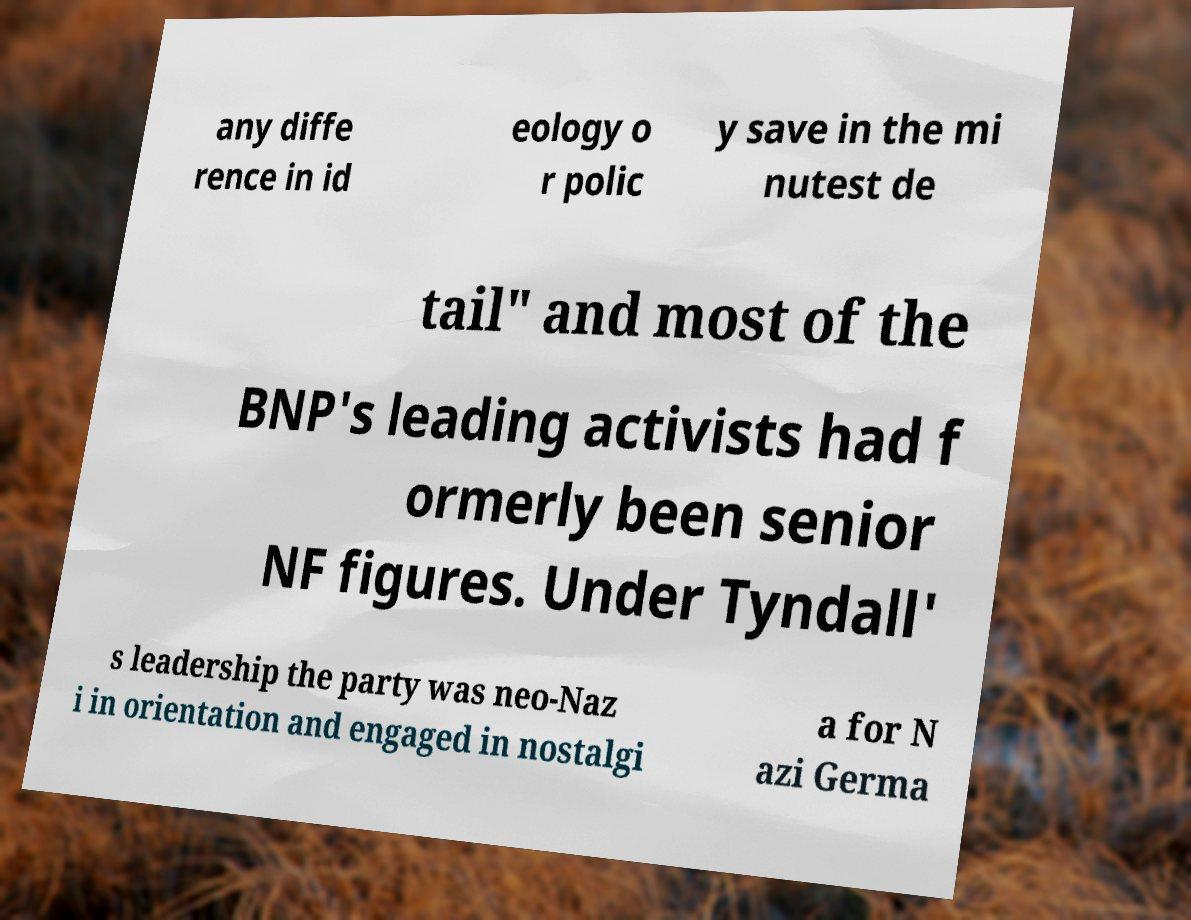I need the written content from this picture converted into text. Can you do that? any diffe rence in id eology o r polic y save in the mi nutest de tail" and most of the BNP's leading activists had f ormerly been senior NF figures. Under Tyndall' s leadership the party was neo-Naz i in orientation and engaged in nostalgi a for N azi Germa 